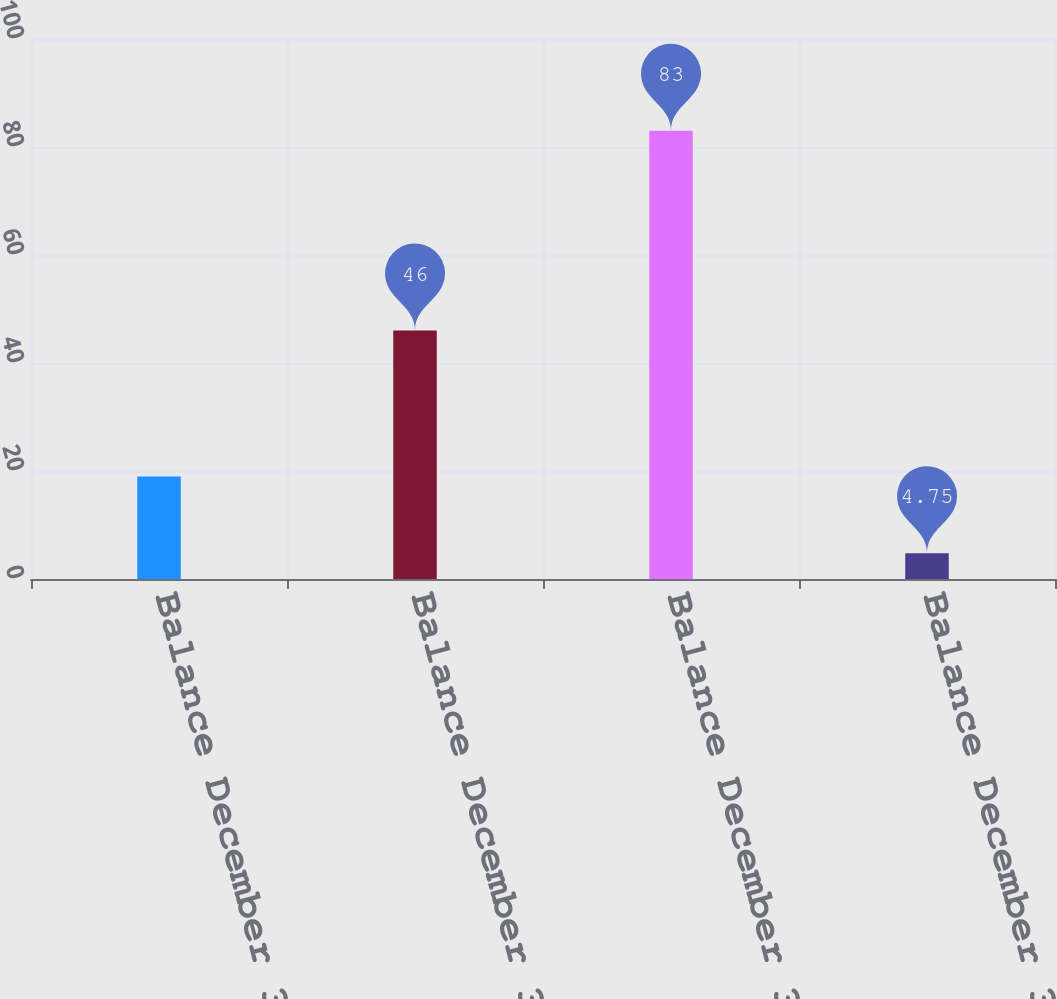<chart> <loc_0><loc_0><loc_500><loc_500><bar_chart><fcel>Balance December 31 2003<fcel>Balance December 31 2004<fcel>Balance December 31 2005<fcel>Balance December 31 2006<nl><fcel>19<fcel>46<fcel>83<fcel>4.75<nl></chart> 